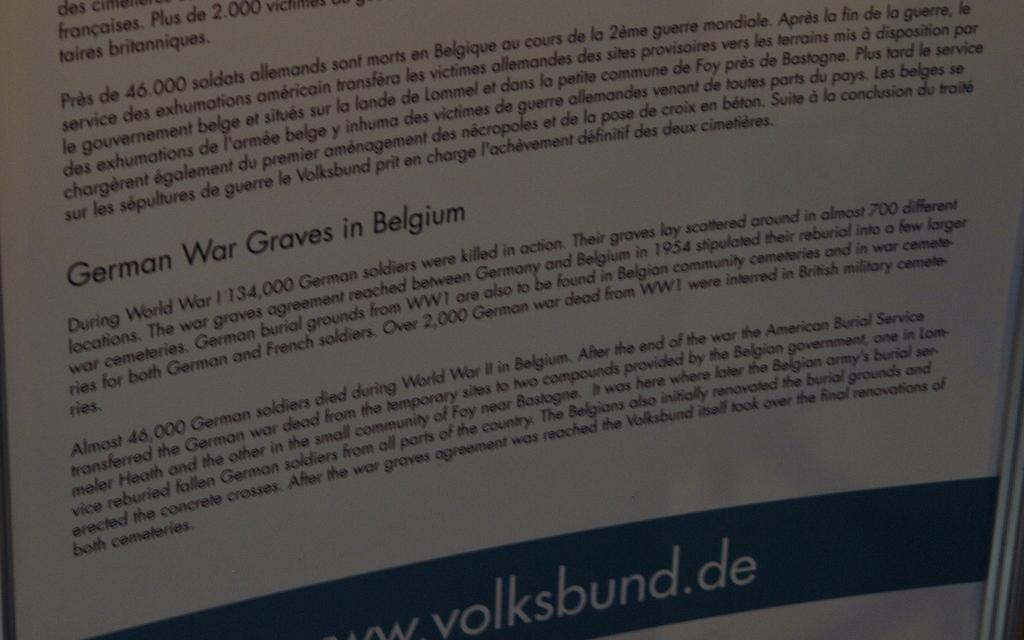<image>
Describe the image concisely. According to the document 134,000 German soldiers were killed in action during World War I. 